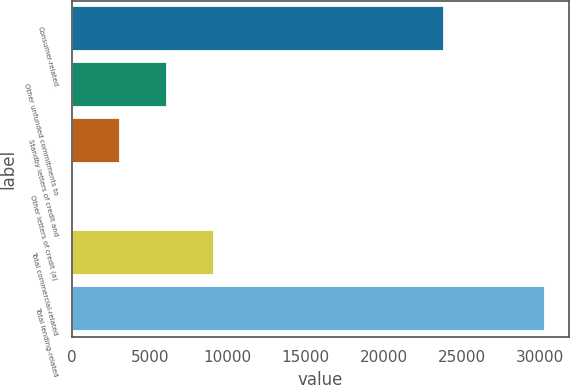Convert chart. <chart><loc_0><loc_0><loc_500><loc_500><bar_chart><fcel>Consumer-related<fcel>Other unfunded commitments to<fcel>Standby letters of credit and<fcel>Other letters of credit (a)<fcel>Total commercial-related<fcel>Total lending-related<nl><fcel>23868<fcel>6099<fcel>3069<fcel>39<fcel>9129<fcel>30339<nl></chart> 